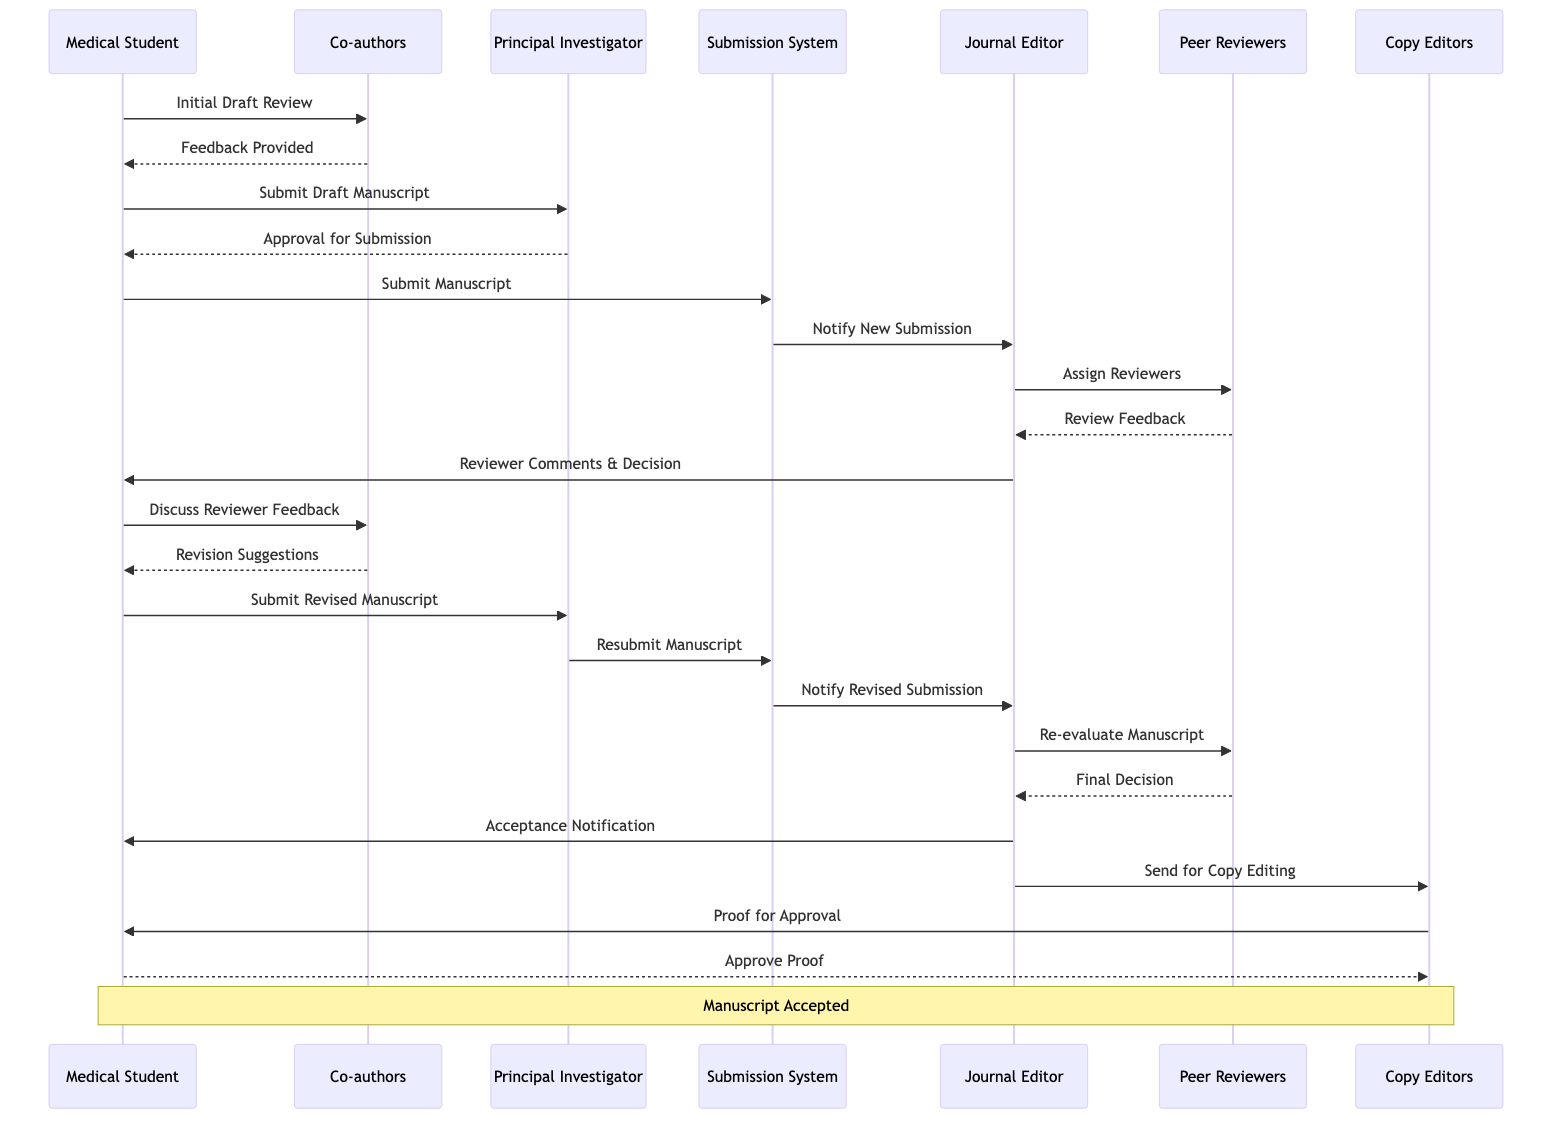What is the first action taken in the workflow? The first action in the workflow is "Initial Draft Review" which is triggered by the Medical Student to the Co-authors.
Answer: Initial Draft Review Who provides feedback after the initial draft review? After the initial draft review, the Co-authors provide feedback to the Medical Student, as indicated by the interaction "Feedback Provided".
Answer: Feedback Provided How many actors are involved in the submission process? The diagram lists six actors involved in the process: Medical Student, Co-authors, Principal Investigator, Journal Editor, Peer Reviewers, and Copy Editors.
Answer: Six What does the Medical Student submit after receiving feedback from the Co-authors? The Medical Student submits the "Draft Manuscript" to the Principal Investigator for approval following the feedback from Co-authors.
Answer: Draft Manuscript What action does the Journal Editor take after receiving the manuscript submission? The Journal Editor takes the action of "Assign Reviewers" after receiving the manuscript submission from the Submission System.
Answer: Assign Reviewers What document is sent to the Medical Student after the peer review process? After the peer review process, the Journal Editor sends "Reviewer Comments & Decision" to the Medical Student, indicating the outcome of the review.
Answer: Reviewer Comments & Decision Which actor is involved in both the acceptance notification and the proof approval processes? The Medical Student is involved in both the "Acceptance Notification" from the Journal Editor and the "Approve Proof" process with the Copy Editors.
Answer: Medical Student What is the final step in the submission workflow? The final step in the workflow is the approval of the proof by the Medical Student after receiving it from the Copy Editors.
Answer: Approve Proof Which actor receives the final decision from the Peer Reviewers? The Journal Editor receives the final decision from the Peer Reviewers, who provide the final verdict after re-evaluating the manuscript.
Answer: Journal Editor What submission system does the Medical Student use to submit the manuscript? The Medical Student uses the "Submission System" to submit the manuscript initially and again for the revised manuscript.
Answer: Submission System 